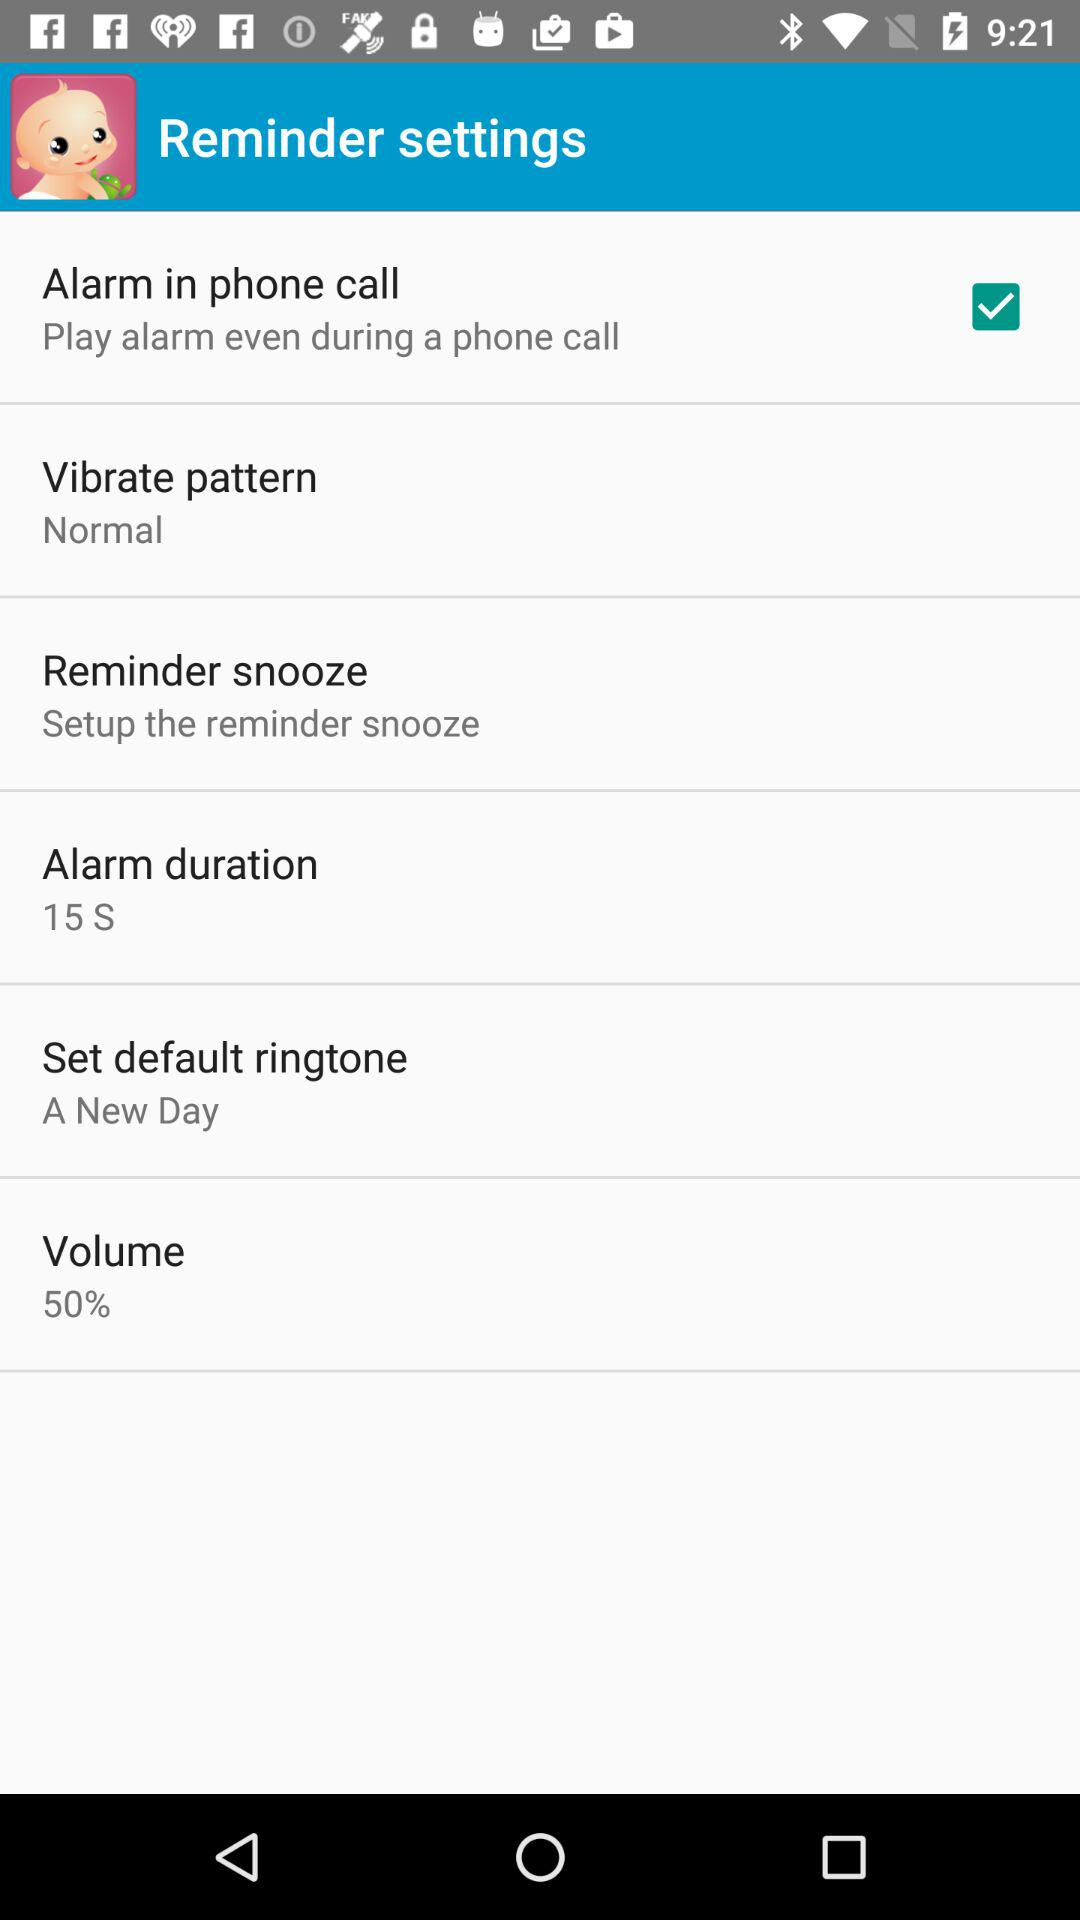What is the vibration pattern? The vibration pattern is normal. 